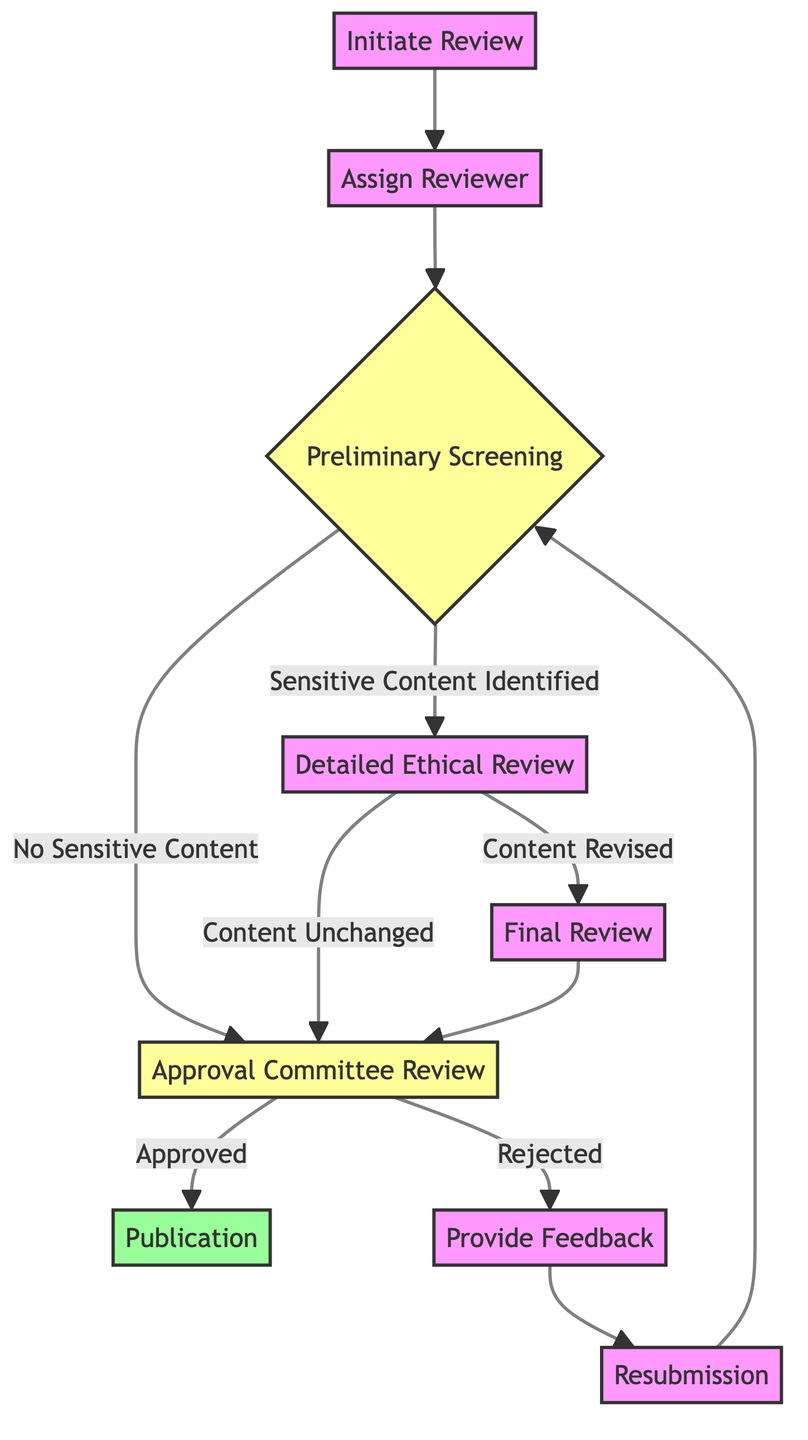What is the first step in the review process? The diagram indicates that the first step is "Initiate Review," which starts the entire ethical review process for media content submission.
Answer: Initiate Review How many main review stages are there? The diagram outlines four main review stages: Initiate Review, Preliminary Screening, Detailed Ethical Review, and Approval Committee Review.
Answer: Four What happens after "Approval Committee Review" if the content is approved? According to the flow chart, if the content is approved during the Approval Committee Review, the next step is "Publication," where the content is prepared for public release.
Answer: Publication If sensitive content is identified, what is the next step? In the flow chart, when sensitive content is identified during the Preliminary Screening, the next step is a "Detailed Ethical Review" to analyze the flagged content in greater depth.
Answer: Detailed Ethical Review What is the process if the content is rejected by the Approval Committee? If the Approval Committee rejects the content, the next step is to "Provide Feedback" to the content creators regarding the rejection and suggested improvements.
Answer: Provide Feedback How does the process resume after providing feedback? After providing feedback, the process resumes with the "Resubmission" step, where content creators are expected to submit revised content for a renewed ethical review.
Answer: Resubmission What happens during the "Final Review"? The "Final Review" serves to re-evaluate any revised content for remaining ethical concerns after the content may have been modified based on previous feedback.
Answer: Re-evaluate revised content What two outcomes can result from the "Approval Committee Review"? The two possible outcomes from the Approval Committee Review are "Approved" or "Rejected," which leads to different subsequent steps.
Answer: Approved or Rejected What is the purpose of the "Detailed Ethical Review"? The purpose of the Detailed Ethical Review is to perform an in-depth analysis of content that has been flagged during the Preliminary Screening for potential ethical concerns.
Answer: In-depth analysis 